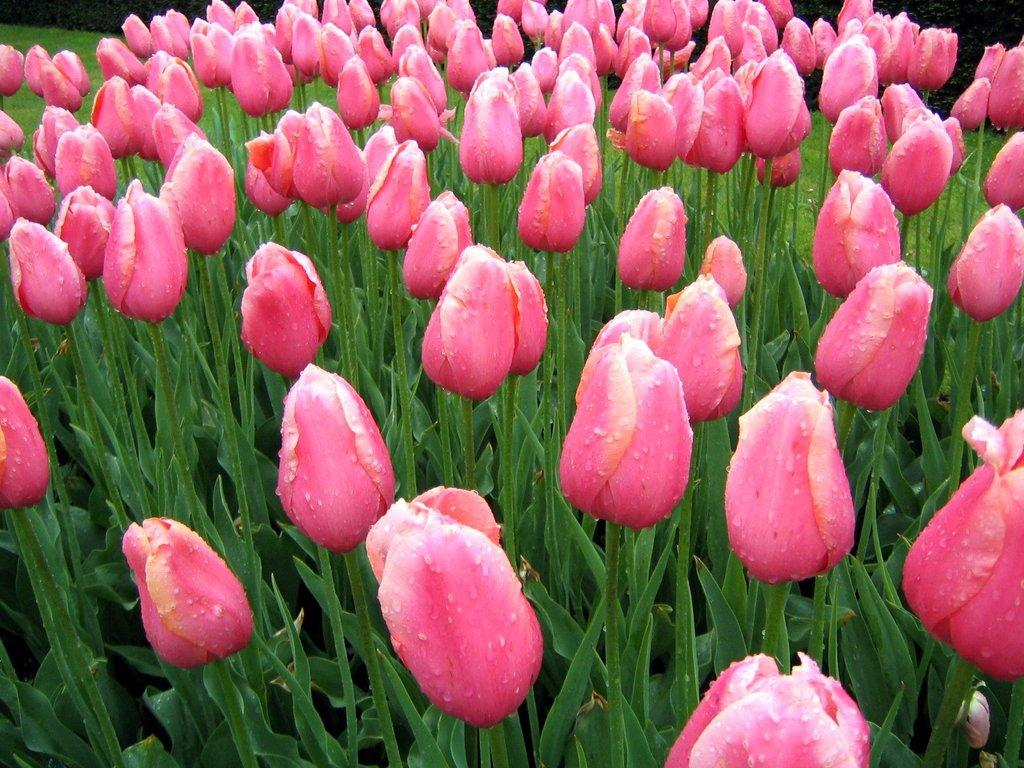What is the main subject of the image? The main subject of the image is a group of plants. What specific feature can be observed on the plants? The plants have flowers. Can you describe the condition of the flowers in the image? There are droplets of water on the flowers. What type of wound can be seen on the tiger in the image? There is no tiger present in the image, and therefore no wound can be observed. 